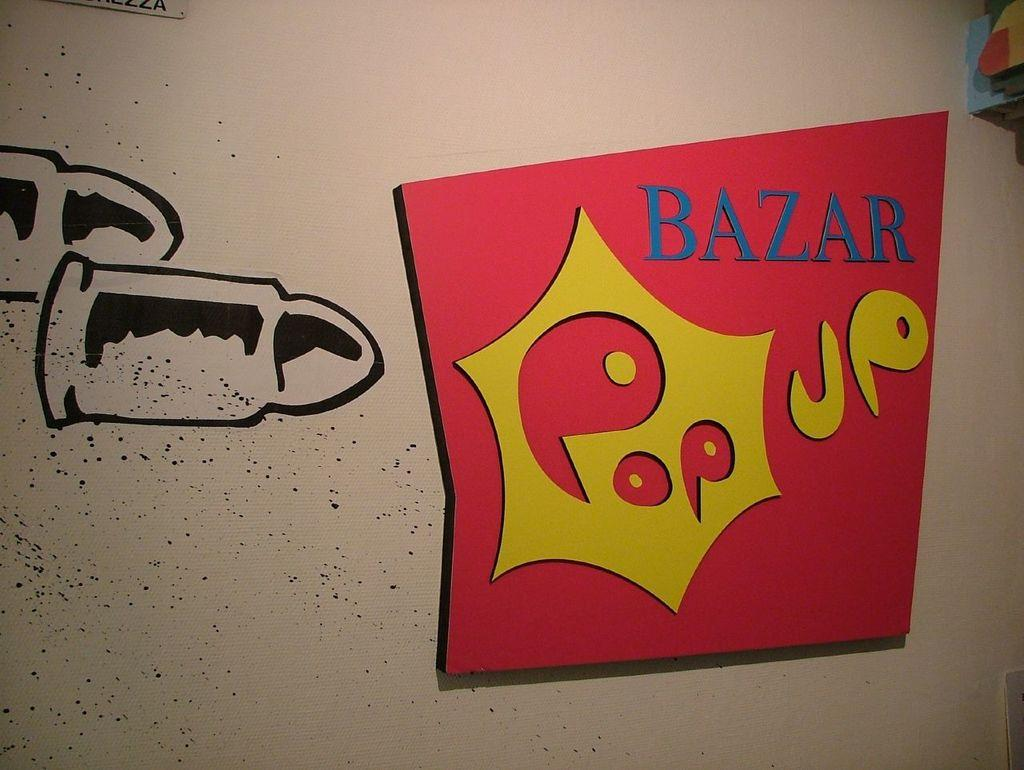What type of artwork is visible in the image? There are paintings in the image. What color is the dress worn by the pest in the image? There is no dress or pest present in the image; it only features paintings. 